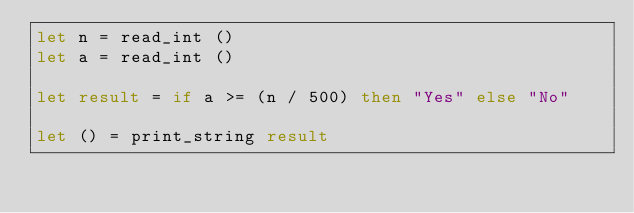Convert code to text. <code><loc_0><loc_0><loc_500><loc_500><_OCaml_>let n = read_int ()
let a = read_int ()
 
let result = if a >= (n / 500) then "Yes" else "No"
 
let () = print_string result</code> 